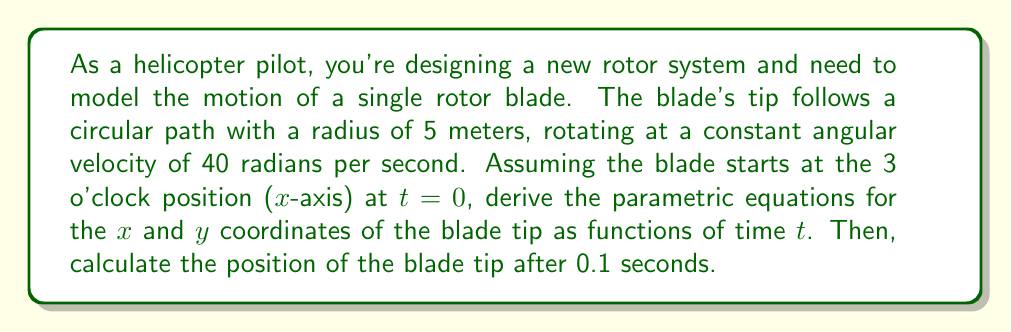Teach me how to tackle this problem. To model the motion of the helicopter rotor blade tip, we'll use parametric equations for circular motion. Let's break this down step-by-step:

1) For a circle with radius r and angular velocity ω, the general parametric equations are:

   $x(t) = r \cos(ωt)$
   $y(t) = r \sin(ωt)$

2) In this case:
   - Radius, $r = 5$ meters
   - Angular velocity, $ω = 40$ radians/second

3) Substituting these values into our general equations:

   $x(t) = 5 \cos(40t)$
   $y(t) = 5 \sin(40t)$

4) These are our final parametric equations for the motion of the blade tip.

5) To find the position after 0.1 seconds, we substitute t = 0.1 into both equations:

   $x(0.1) = 5 \cos(40 * 0.1) = 5 \cos(4) ≈ -1.33$ meters
   $y(0.1) = 5 \sin(40 * 0.1) = 5 \sin(4) ≈ 4.81$ meters

6) Therefore, after 0.1 seconds, the blade tip will be at approximately (-1.33, 4.81) in the xy-plane.

[asy]
size(200);
draw(circle((0,0),5));
draw((-5,0)--(5,0),arrow=Arrow);
draw((0,-5)--(0,5),arrow=Arrow);
dot((-1.33,4.81),red);
label("(x,y)",(-1.33,4.81),NE,red);
label("5m",(2.5,0),SE);
[/asy]
Answer: Parametric equations: $x(t) = 5 \cos(40t)$, $y(t) = 5 \sin(40t)$
Position at t = 0.1s: $(-1.33, 4.81)$ meters 